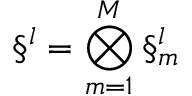Convert formula to latex. <formula><loc_0><loc_0><loc_500><loc_500>\S ^ { l } = \bigotimes _ { m = 1 } ^ { M } \S _ { m } ^ { l }</formula> 